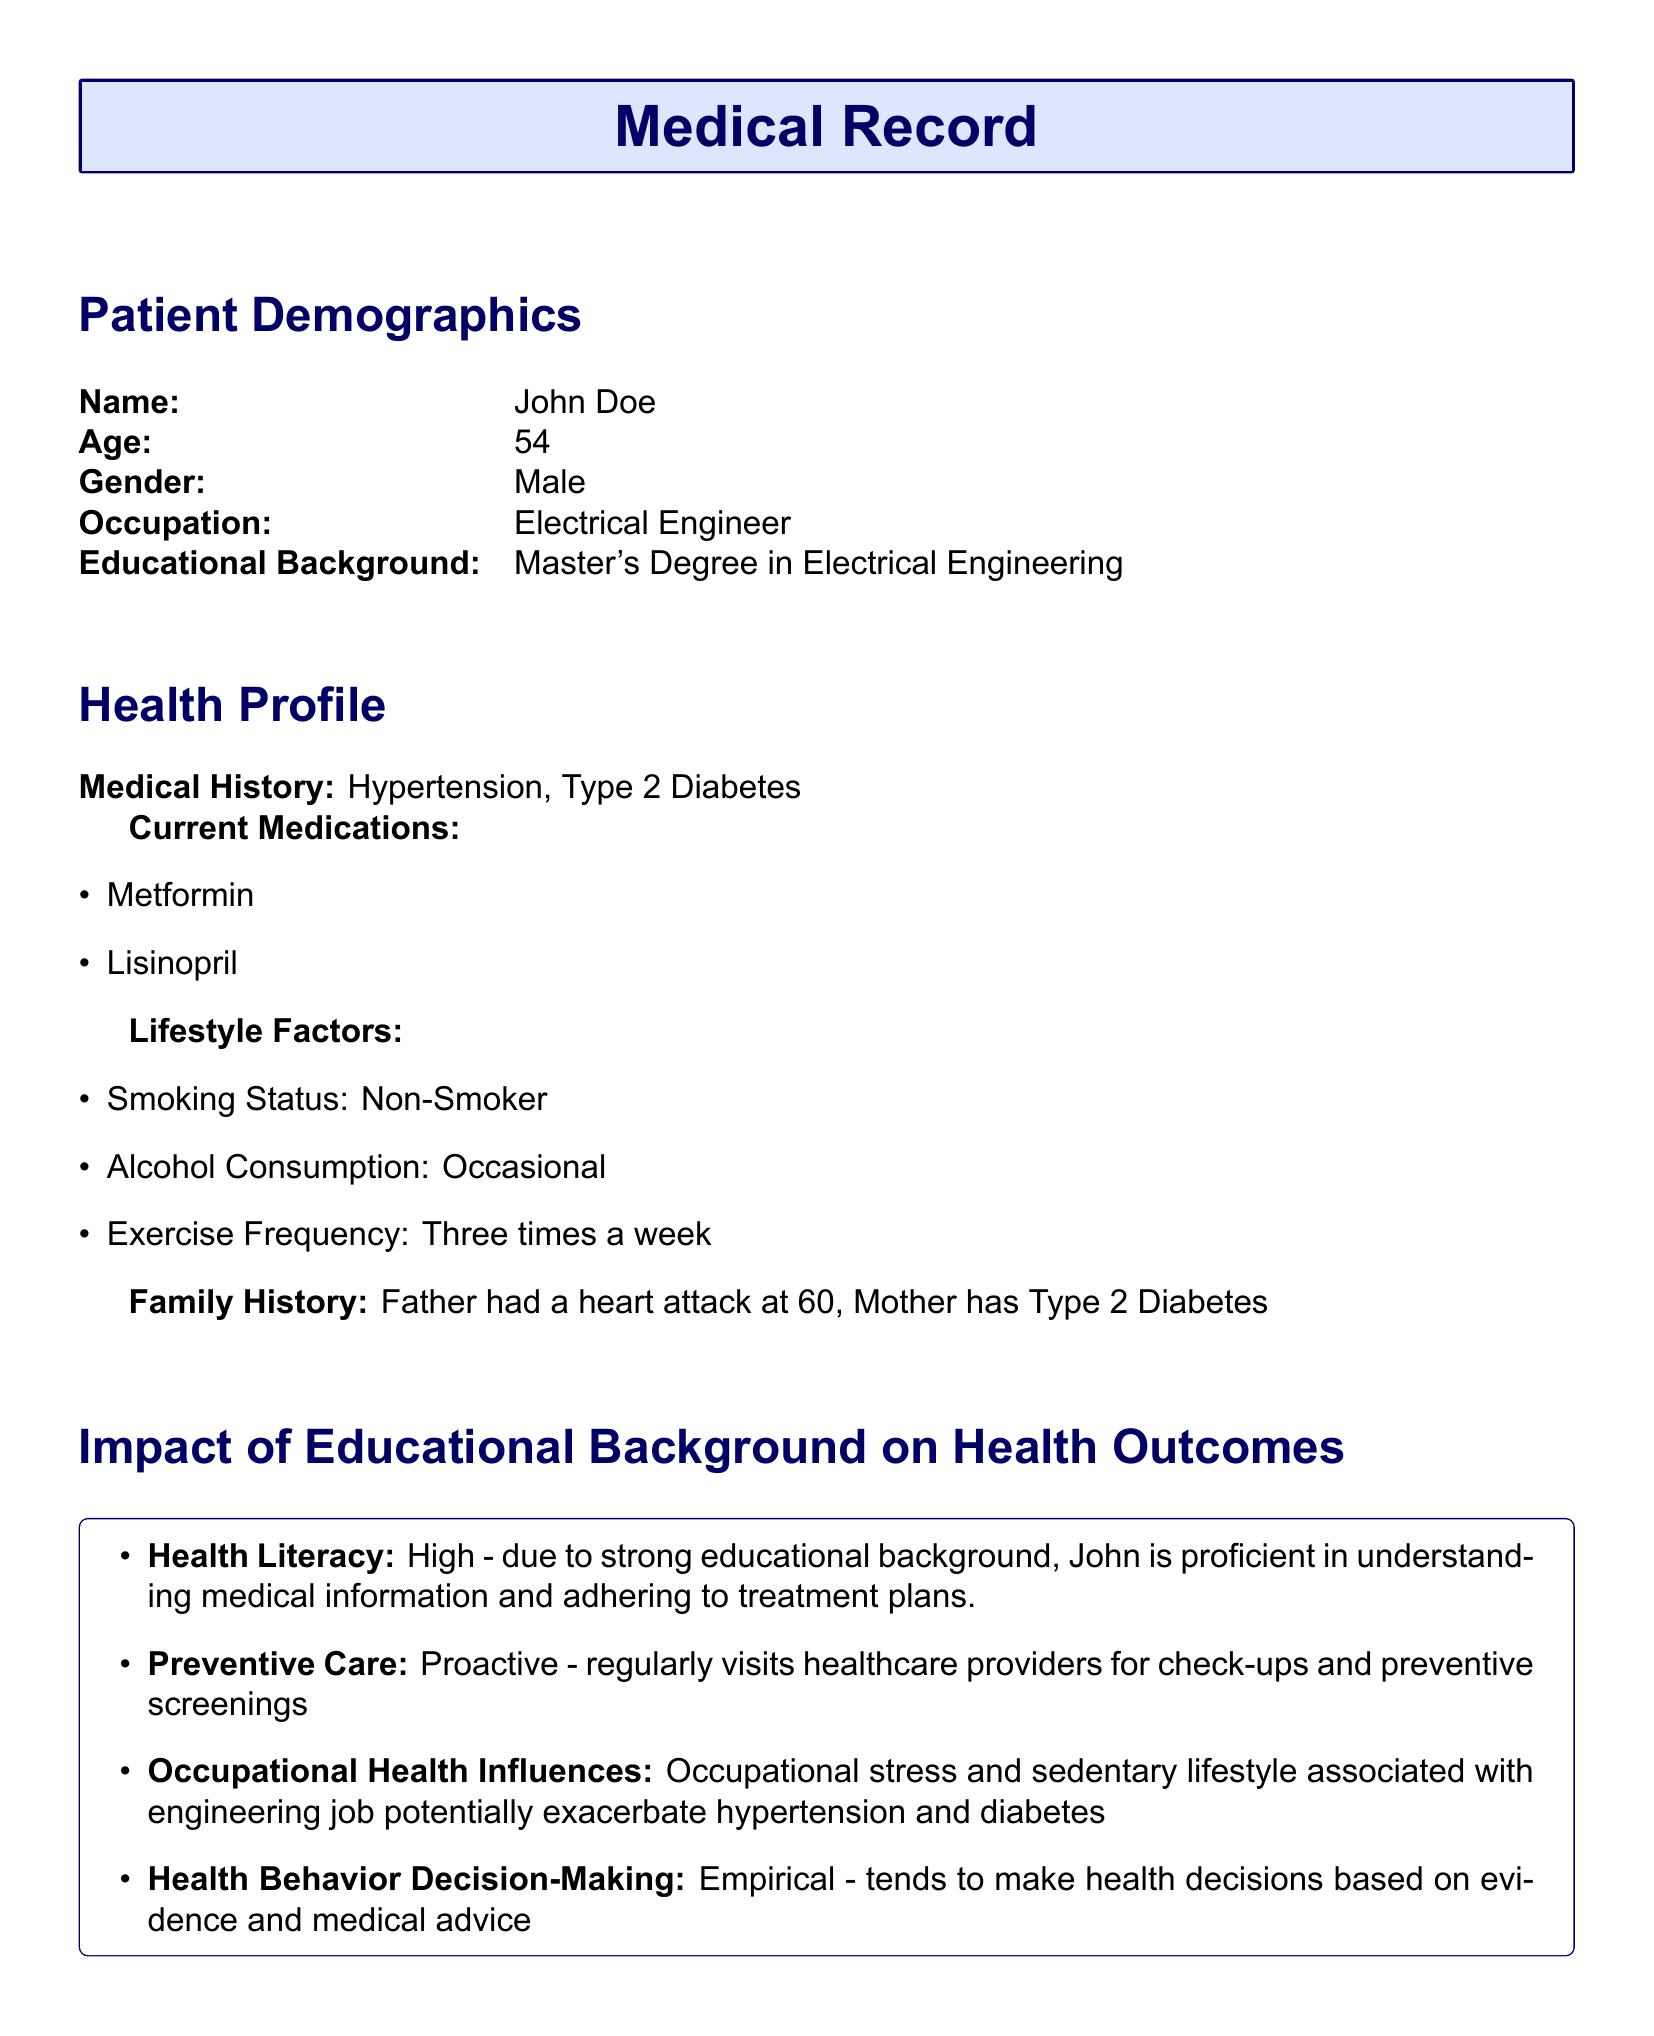What is the patient's name? The patient's name is stated under Patient Demographics, specifically mentioning "John Doe".
Answer: John Doe What is the patient's age? The patient's age is recorded in the Patient Demographics section as "54".
Answer: 54 What is the patient's occupation? The patient's occupation is listed in the document as "Electrical Engineer".
Answer: Electrical Engineer What is the highest level of education attained by the patient? The educational background indicates that the highest degree is a "Master's Degree in Electrical Engineering".
Answer: Master's Degree in Electrical Engineering What medical condition does the patient have? The patient's medical history includes "Hypertension" and "Type 2 Diabetes".
Answer: Hypertension, Type 2 Diabetes How often does the patient exercise? The Lifestyle Factors section states that the patient exercises "Three times a week".
Answer: Three times a week What is the patient's smoking status? The document specifies that the patient's smoking status is "Non-Smoker".
Answer: Non-Smoker What factors may exacerbate the patient's health conditions? The document mentions "Occupational stress and sedentary lifestyle" as factors in the patient's health profile.
Answer: Occupational stress and sedentary lifestyle What is the level of health literacy for this patient? The document indicates that the patient's health literacy is "High".
Answer: High Does the patient tend to make health decisions based on evidence? Yes, the document notes that the patient makes health decisions based on "evidence and medical advice".
Answer: Yes 